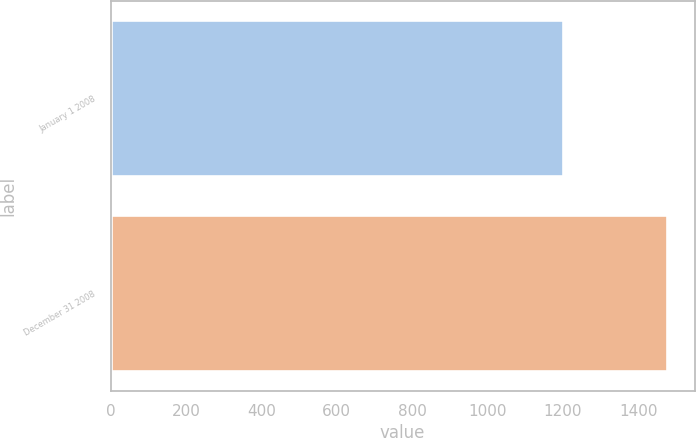<chart> <loc_0><loc_0><loc_500><loc_500><bar_chart><fcel>January 1 2008<fcel>December 31 2008<nl><fcel>1201.7<fcel>1476.3<nl></chart> 